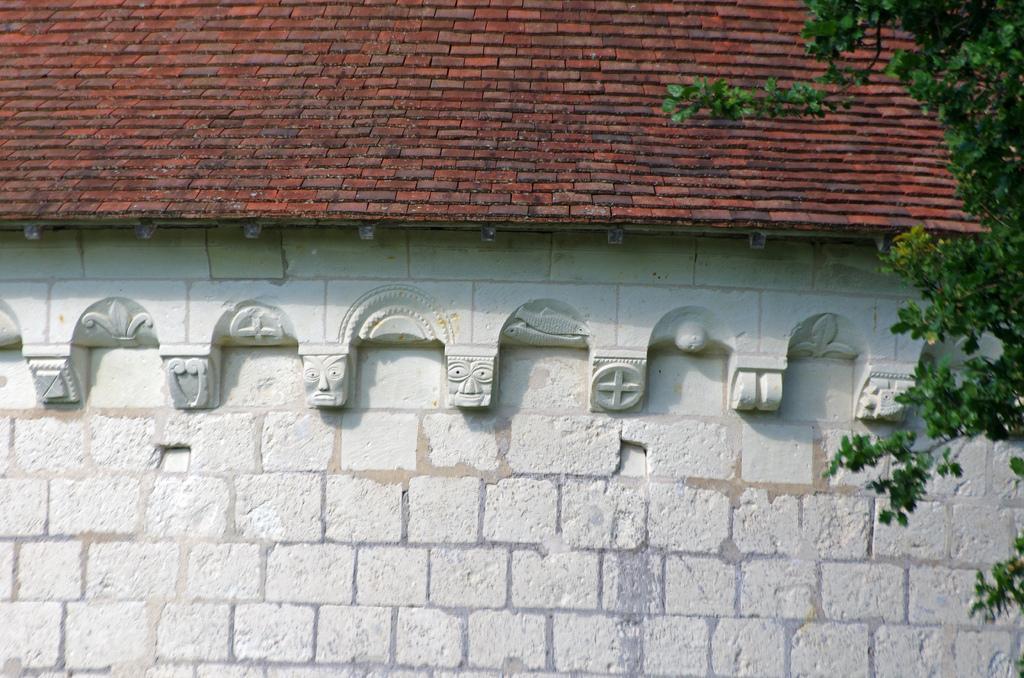Can you describe this image briefly? This is the picture of a building. In this image there are roof tiles on the top of the building. On the right side of the image there is a tree. 